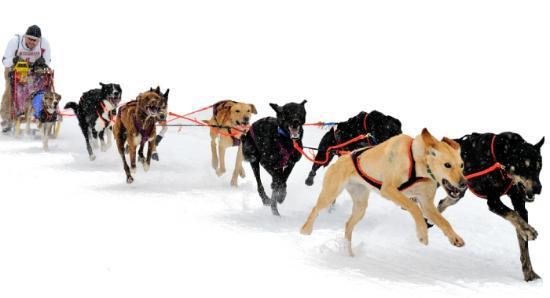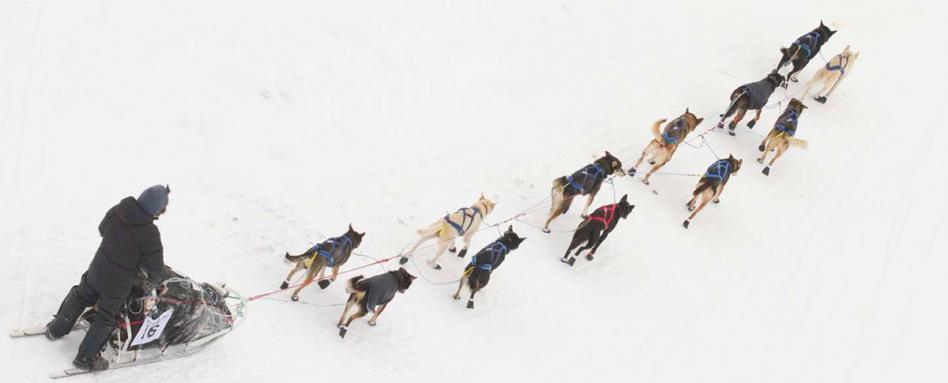The first image is the image on the left, the second image is the image on the right. Given the left and right images, does the statement "The leading dogs are blonde/gold, and black with a lighter muzzle." hold true? Answer yes or no. Yes. The first image is the image on the left, the second image is the image on the right. Assess this claim about the two images: "The dog teams in the two images are each forward-facing, but headed in different directions.". Correct or not? Answer yes or no. No. 